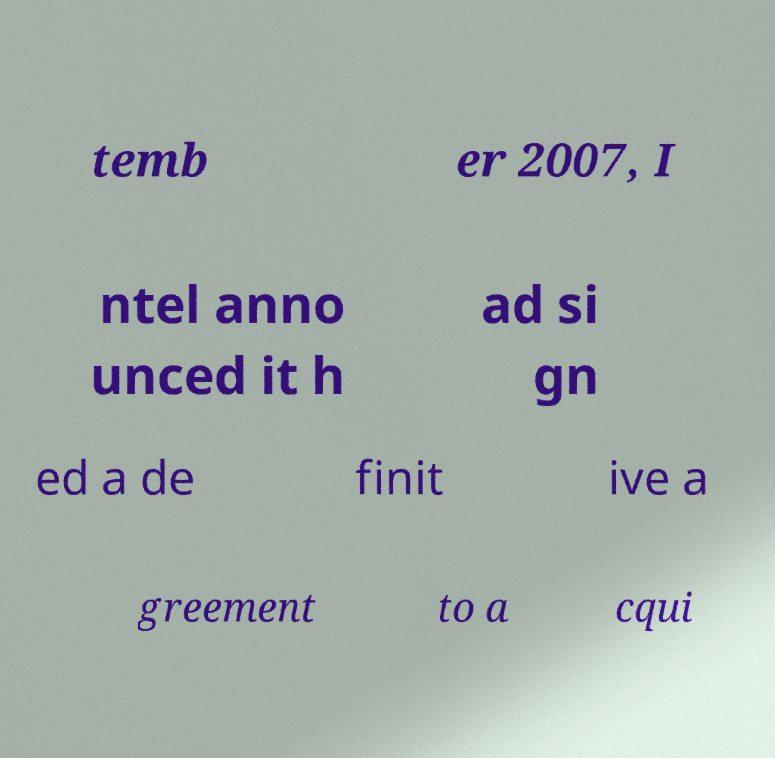Can you accurately transcribe the text from the provided image for me? temb er 2007, I ntel anno unced it h ad si gn ed a de finit ive a greement to a cqui 